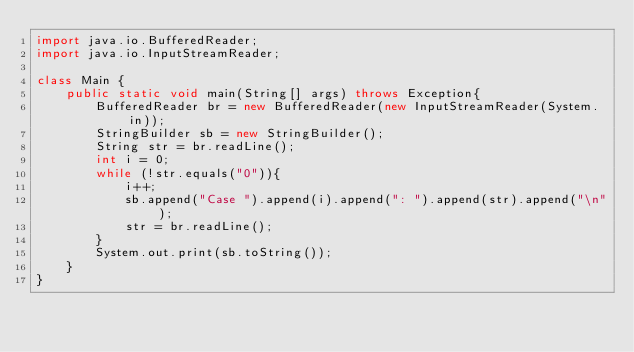<code> <loc_0><loc_0><loc_500><loc_500><_Java_>import java.io.BufferedReader;
import java.io.InputStreamReader;
 
class Main {
    public static void main(String[] args) throws Exception{
        BufferedReader br = new BufferedReader(new InputStreamReader(System.in));
        StringBuilder sb = new StringBuilder();
        String str = br.readLine();
        int i = 0;
        while (!str.equals("0")){
            i++;
            sb.append("Case ").append(i).append(": ").append(str).append("\n");
            str = br.readLine();
        }
        System.out.print(sb.toString());
    }
}</code> 